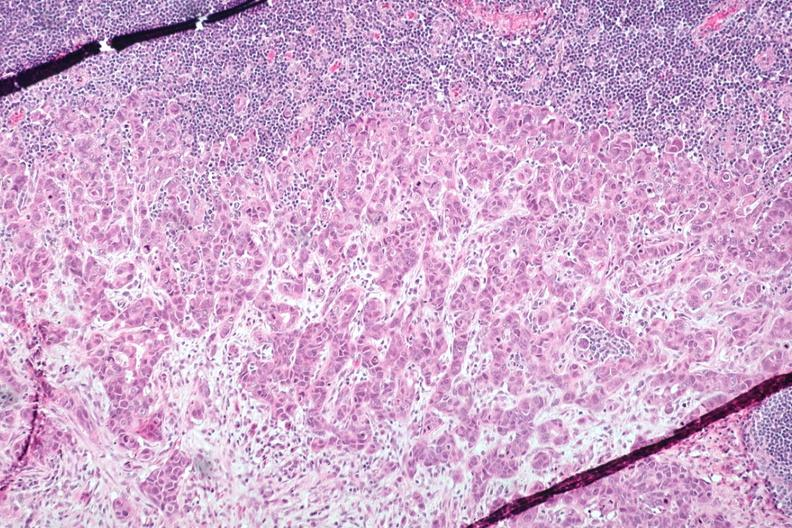what does this image show?
Answer the question using a single word or phrase. Med neoplastic ducts with desmoplastic reaction lymph node tissue atone margin and 